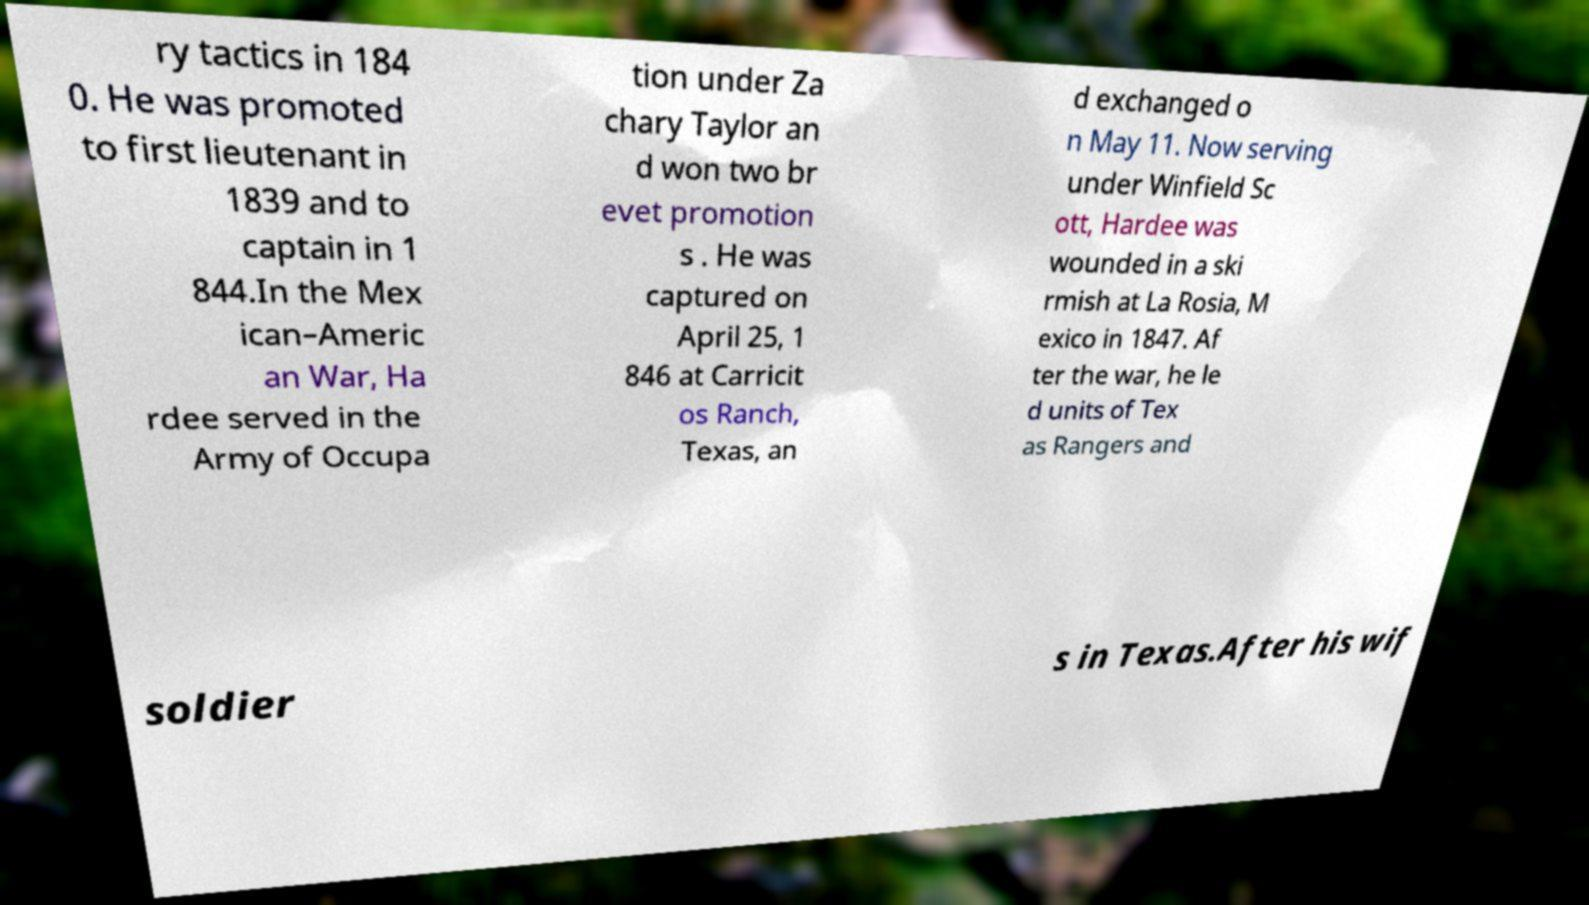Can you accurately transcribe the text from the provided image for me? ry tactics in 184 0. He was promoted to first lieutenant in 1839 and to captain in 1 844.In the Mex ican–Americ an War, Ha rdee served in the Army of Occupa tion under Za chary Taylor an d won two br evet promotion s . He was captured on April 25, 1 846 at Carricit os Ranch, Texas, an d exchanged o n May 11. Now serving under Winfield Sc ott, Hardee was wounded in a ski rmish at La Rosia, M exico in 1847. Af ter the war, he le d units of Tex as Rangers and soldier s in Texas.After his wif 